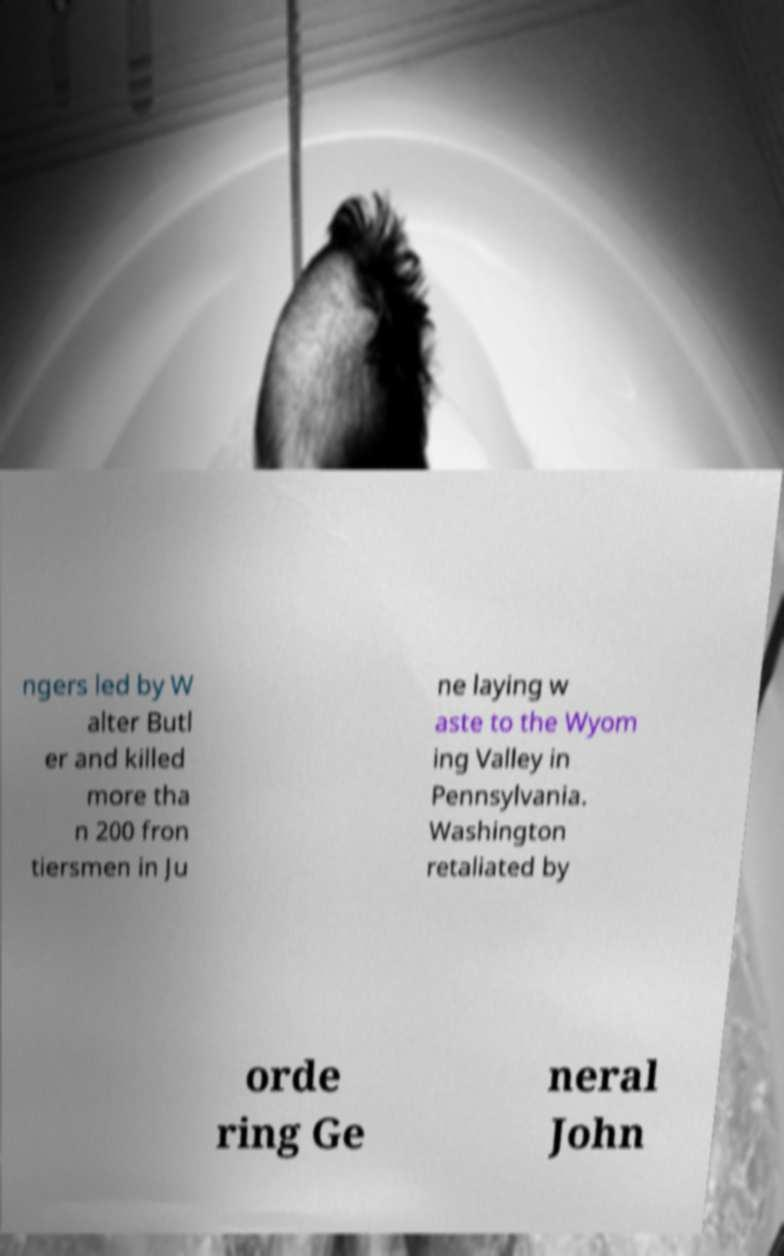Please identify and transcribe the text found in this image. ngers led by W alter Butl er and killed more tha n 200 fron tiersmen in Ju ne laying w aste to the Wyom ing Valley in Pennsylvania. Washington retaliated by orde ring Ge neral John 